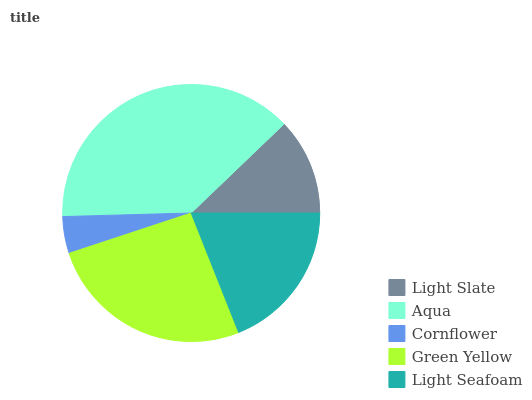Is Cornflower the minimum?
Answer yes or no. Yes. Is Aqua the maximum?
Answer yes or no. Yes. Is Aqua the minimum?
Answer yes or no. No. Is Cornflower the maximum?
Answer yes or no. No. Is Aqua greater than Cornflower?
Answer yes or no. Yes. Is Cornflower less than Aqua?
Answer yes or no. Yes. Is Cornflower greater than Aqua?
Answer yes or no. No. Is Aqua less than Cornflower?
Answer yes or no. No. Is Light Seafoam the high median?
Answer yes or no. Yes. Is Light Seafoam the low median?
Answer yes or no. Yes. Is Light Slate the high median?
Answer yes or no. No. Is Cornflower the low median?
Answer yes or no. No. 